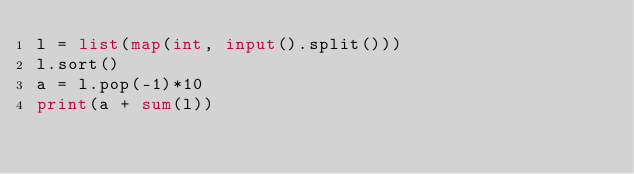<code> <loc_0><loc_0><loc_500><loc_500><_Python_>l = list(map(int, input().split()))
l.sort()
a = l.pop(-1)*10
print(a + sum(l))
</code> 